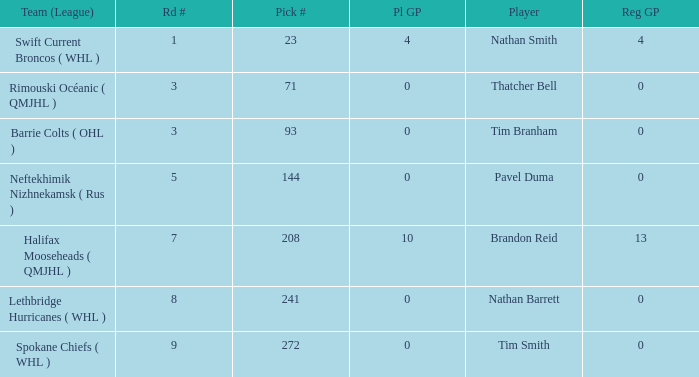How many reg GP for nathan barrett in a round less than 8? 0.0. 